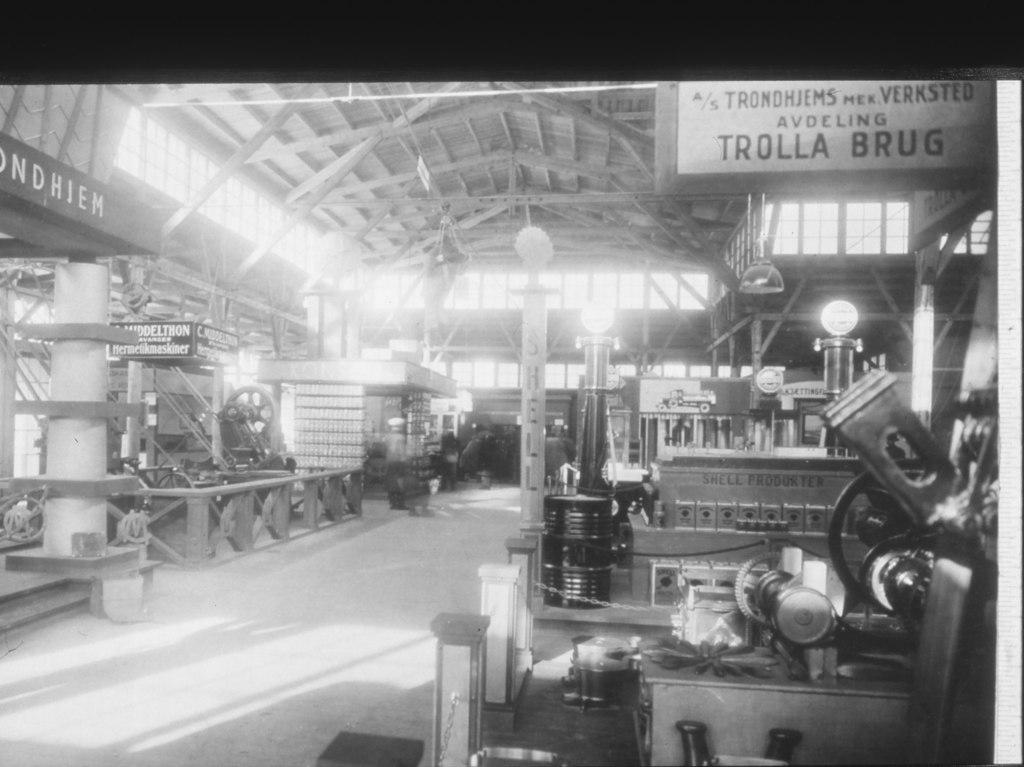Please provide a concise description of this image. This is a black and white image and here we can see machines, lights, chains, boards and some other objects. At the bottom, there is a floor and at the top, there is a roof. 